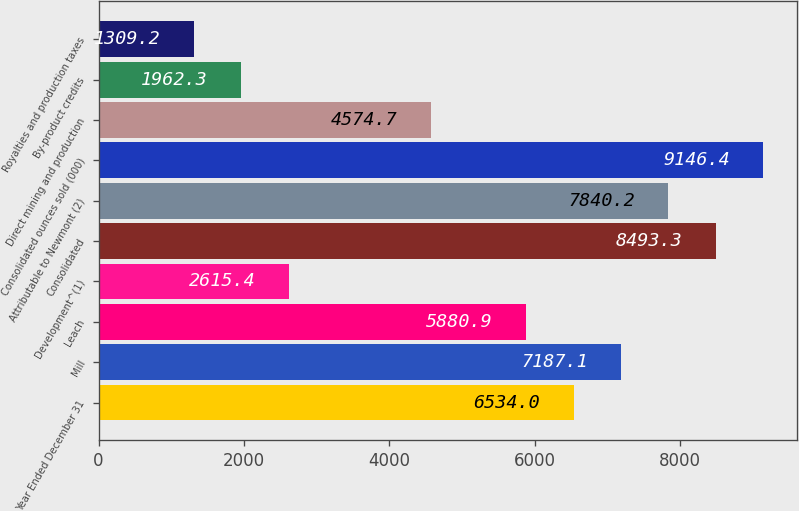Convert chart to OTSL. <chart><loc_0><loc_0><loc_500><loc_500><bar_chart><fcel>Year Ended December 31<fcel>Mill<fcel>Leach<fcel>Development^(1)<fcel>Consolidated<fcel>Attributable to Newmont (2)<fcel>Consolidated ounces sold (000)<fcel>Direct mining and production<fcel>By-product credits<fcel>Royalties and production taxes<nl><fcel>6534<fcel>7187.1<fcel>5880.9<fcel>2615.4<fcel>8493.3<fcel>7840.2<fcel>9146.4<fcel>4574.7<fcel>1962.3<fcel>1309.2<nl></chart> 